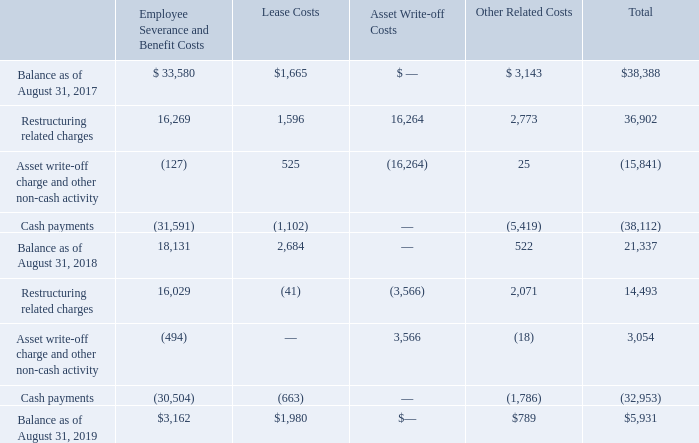2017 Restructuring Plan
On September 15, 2016, the Company’s Board of Directors formally approved a restructuring plan to better align the Company’s global capacity and administrative support infrastructure to further optimize organizational effectiveness. This action includes headcount reductions across the Company’s selling, general and administrative cost base and capacity realignment in higher cost locations (the “2017 Restructuring Plan”).
The 2017 Restructuring Plan, totaling $195.0 million in restructuring and other related costs, is complete as of August 31, 2019.
The tables below summarize the Company’s liability activity, primarily associated with the 2017 Restructuring Plan (in thousands):
Why did the Company's Board of Directors formally approve a restructuring plan on September 15, 2016? To better align the company’s global capacity and administrative support infrastructure to further optimize organizational effectiveness. What was the total balance as of August 31, 2017?
Answer scale should be: thousand. $38,388. What was the total balance as of August 31, 2019?
Answer scale should be: thousand. $5,931. What is the change in the balance as of August in Employee Severance and Benefit Costs between 2017 and 2018?
Answer scale should be: thousand. 18,131-33,580
Answer: -15449. What were the lease costs in 2017 as a percentage of the total balance in 2017?
Answer scale should be: percent. 1,665/38,388
Answer: 4.34. What was the percentage change in the total balance between 2018 and 2019?
Answer scale should be: percent. (5,931-21,337)/21,337
Answer: -72.2. 